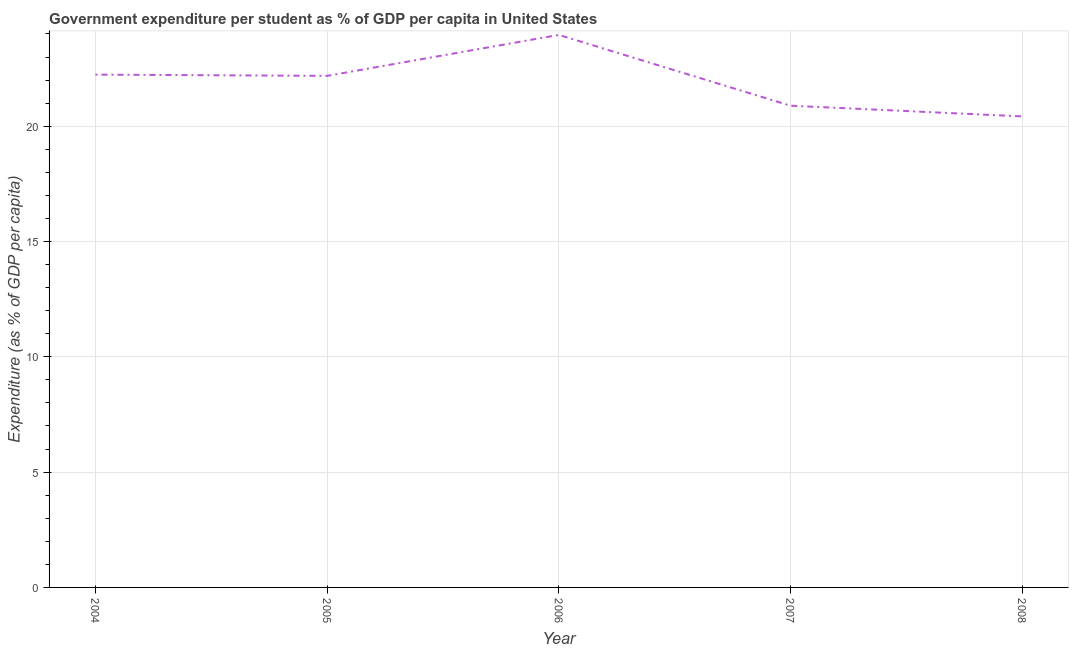What is the government expenditure per student in 2007?
Offer a very short reply. 20.89. Across all years, what is the maximum government expenditure per student?
Offer a very short reply. 23.96. Across all years, what is the minimum government expenditure per student?
Provide a succinct answer. 20.43. In which year was the government expenditure per student maximum?
Your response must be concise. 2006. What is the sum of the government expenditure per student?
Give a very brief answer. 109.69. What is the difference between the government expenditure per student in 2007 and 2008?
Offer a very short reply. 0.46. What is the average government expenditure per student per year?
Provide a short and direct response. 21.94. What is the median government expenditure per student?
Keep it short and to the point. 22.18. In how many years, is the government expenditure per student greater than 22 %?
Provide a short and direct response. 3. Do a majority of the years between 2006 and 2005 (inclusive) have government expenditure per student greater than 12 %?
Provide a short and direct response. No. What is the ratio of the government expenditure per student in 2004 to that in 2007?
Make the answer very short. 1.06. Is the government expenditure per student in 2005 less than that in 2007?
Make the answer very short. No. Is the difference between the government expenditure per student in 2004 and 2006 greater than the difference between any two years?
Your response must be concise. No. What is the difference between the highest and the second highest government expenditure per student?
Give a very brief answer. 1.72. What is the difference between the highest and the lowest government expenditure per student?
Provide a short and direct response. 3.53. How many lines are there?
Your response must be concise. 1. Does the graph contain any zero values?
Make the answer very short. No. What is the title of the graph?
Ensure brevity in your answer.  Government expenditure per student as % of GDP per capita in United States. What is the label or title of the X-axis?
Your answer should be very brief. Year. What is the label or title of the Y-axis?
Give a very brief answer. Expenditure (as % of GDP per capita). What is the Expenditure (as % of GDP per capita) of 2004?
Provide a short and direct response. 22.24. What is the Expenditure (as % of GDP per capita) in 2005?
Provide a succinct answer. 22.18. What is the Expenditure (as % of GDP per capita) of 2006?
Make the answer very short. 23.96. What is the Expenditure (as % of GDP per capita) in 2007?
Offer a very short reply. 20.89. What is the Expenditure (as % of GDP per capita) in 2008?
Offer a terse response. 20.43. What is the difference between the Expenditure (as % of GDP per capita) in 2004 and 2005?
Make the answer very short. 0.05. What is the difference between the Expenditure (as % of GDP per capita) in 2004 and 2006?
Provide a succinct answer. -1.72. What is the difference between the Expenditure (as % of GDP per capita) in 2004 and 2007?
Your response must be concise. 1.35. What is the difference between the Expenditure (as % of GDP per capita) in 2004 and 2008?
Offer a terse response. 1.81. What is the difference between the Expenditure (as % of GDP per capita) in 2005 and 2006?
Offer a very short reply. -1.78. What is the difference between the Expenditure (as % of GDP per capita) in 2005 and 2007?
Make the answer very short. 1.29. What is the difference between the Expenditure (as % of GDP per capita) in 2005 and 2008?
Provide a short and direct response. 1.76. What is the difference between the Expenditure (as % of GDP per capita) in 2006 and 2007?
Offer a terse response. 3.07. What is the difference between the Expenditure (as % of GDP per capita) in 2006 and 2008?
Provide a short and direct response. 3.53. What is the difference between the Expenditure (as % of GDP per capita) in 2007 and 2008?
Give a very brief answer. 0.46. What is the ratio of the Expenditure (as % of GDP per capita) in 2004 to that in 2005?
Give a very brief answer. 1. What is the ratio of the Expenditure (as % of GDP per capita) in 2004 to that in 2006?
Provide a succinct answer. 0.93. What is the ratio of the Expenditure (as % of GDP per capita) in 2004 to that in 2007?
Offer a terse response. 1.06. What is the ratio of the Expenditure (as % of GDP per capita) in 2004 to that in 2008?
Provide a succinct answer. 1.09. What is the ratio of the Expenditure (as % of GDP per capita) in 2005 to that in 2006?
Offer a very short reply. 0.93. What is the ratio of the Expenditure (as % of GDP per capita) in 2005 to that in 2007?
Make the answer very short. 1.06. What is the ratio of the Expenditure (as % of GDP per capita) in 2005 to that in 2008?
Offer a very short reply. 1.09. What is the ratio of the Expenditure (as % of GDP per capita) in 2006 to that in 2007?
Your answer should be compact. 1.15. What is the ratio of the Expenditure (as % of GDP per capita) in 2006 to that in 2008?
Give a very brief answer. 1.17. What is the ratio of the Expenditure (as % of GDP per capita) in 2007 to that in 2008?
Give a very brief answer. 1.02. 